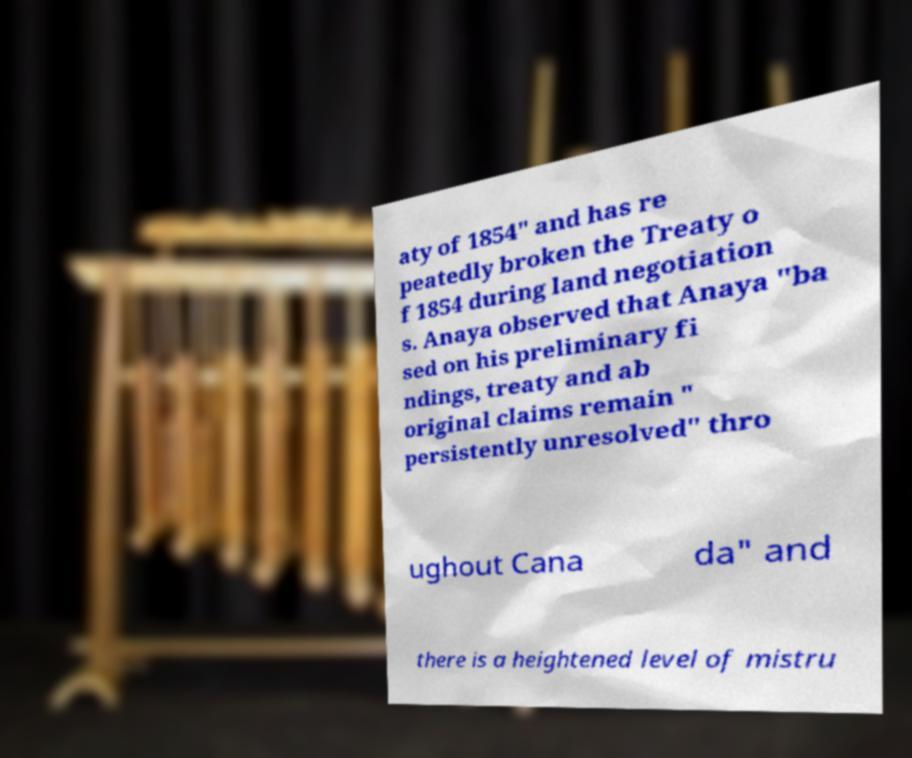What messages or text are displayed in this image? I need them in a readable, typed format. aty of 1854" and has re peatedly broken the Treaty o f 1854 during land negotiation s. Anaya observed that Anaya "ba sed on his preliminary fi ndings, treaty and ab original claims remain " persistently unresolved" thro ughout Cana da" and there is a heightened level of mistru 